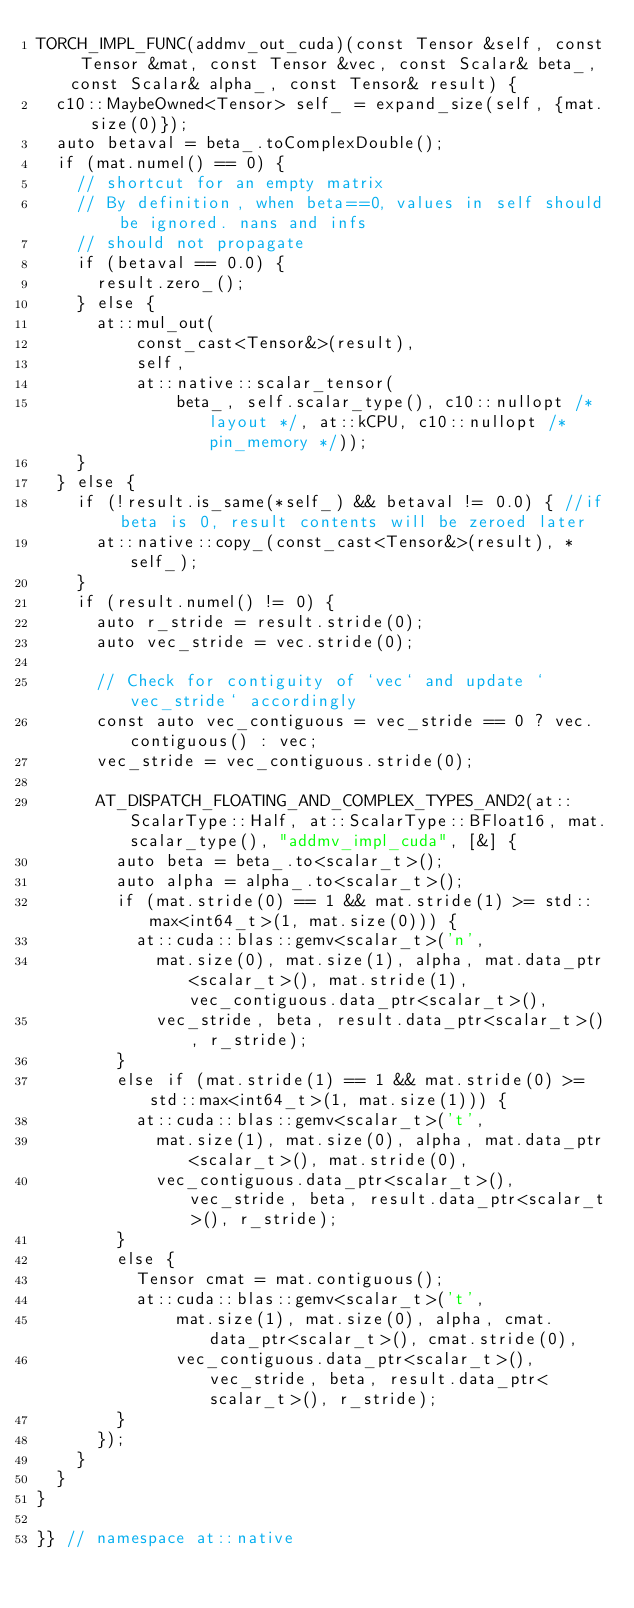Convert code to text. <code><loc_0><loc_0><loc_500><loc_500><_Cuda_>TORCH_IMPL_FUNC(addmv_out_cuda)(const Tensor &self, const Tensor &mat, const Tensor &vec, const Scalar& beta_, const Scalar& alpha_, const Tensor& result) {
  c10::MaybeOwned<Tensor> self_ = expand_size(self, {mat.size(0)});
  auto betaval = beta_.toComplexDouble();
  if (mat.numel() == 0) {
    // shortcut for an empty matrix
    // By definition, when beta==0, values in self should be ignored. nans and infs
    // should not propagate
    if (betaval == 0.0) {
      result.zero_();
    } else {
      at::mul_out(
          const_cast<Tensor&>(result),
          self,
          at::native::scalar_tensor(
              beta_, self.scalar_type(), c10::nullopt /* layout */, at::kCPU, c10::nullopt /* pin_memory */));
    }
  } else {
    if (!result.is_same(*self_) && betaval != 0.0) { //if beta is 0, result contents will be zeroed later
      at::native::copy_(const_cast<Tensor&>(result), *self_);
    }
    if (result.numel() != 0) {
      auto r_stride = result.stride(0);
      auto vec_stride = vec.stride(0);

      // Check for contiguity of `vec` and update `vec_stride` accordingly
      const auto vec_contiguous = vec_stride == 0 ? vec.contiguous() : vec;
      vec_stride = vec_contiguous.stride(0);

      AT_DISPATCH_FLOATING_AND_COMPLEX_TYPES_AND2(at::ScalarType::Half, at::ScalarType::BFloat16, mat.scalar_type(), "addmv_impl_cuda", [&] {
        auto beta = beta_.to<scalar_t>();
        auto alpha = alpha_.to<scalar_t>();
        if (mat.stride(0) == 1 && mat.stride(1) >= std::max<int64_t>(1, mat.size(0))) {
          at::cuda::blas::gemv<scalar_t>('n',
            mat.size(0), mat.size(1), alpha, mat.data_ptr<scalar_t>(), mat.stride(1), vec_contiguous.data_ptr<scalar_t>(),
            vec_stride, beta, result.data_ptr<scalar_t>(), r_stride);
        }
        else if (mat.stride(1) == 1 && mat.stride(0) >= std::max<int64_t>(1, mat.size(1))) {
          at::cuda::blas::gemv<scalar_t>('t',
            mat.size(1), mat.size(0), alpha, mat.data_ptr<scalar_t>(), mat.stride(0),
            vec_contiguous.data_ptr<scalar_t>(), vec_stride, beta, result.data_ptr<scalar_t>(), r_stride);
        }
        else {
          Tensor cmat = mat.contiguous();
          at::cuda::blas::gemv<scalar_t>('t',
              mat.size(1), mat.size(0), alpha, cmat.data_ptr<scalar_t>(), cmat.stride(0),
              vec_contiguous.data_ptr<scalar_t>(), vec_stride, beta, result.data_ptr<scalar_t>(), r_stride);
        }
      });
    }
  }
}

}} // namespace at::native
</code> 